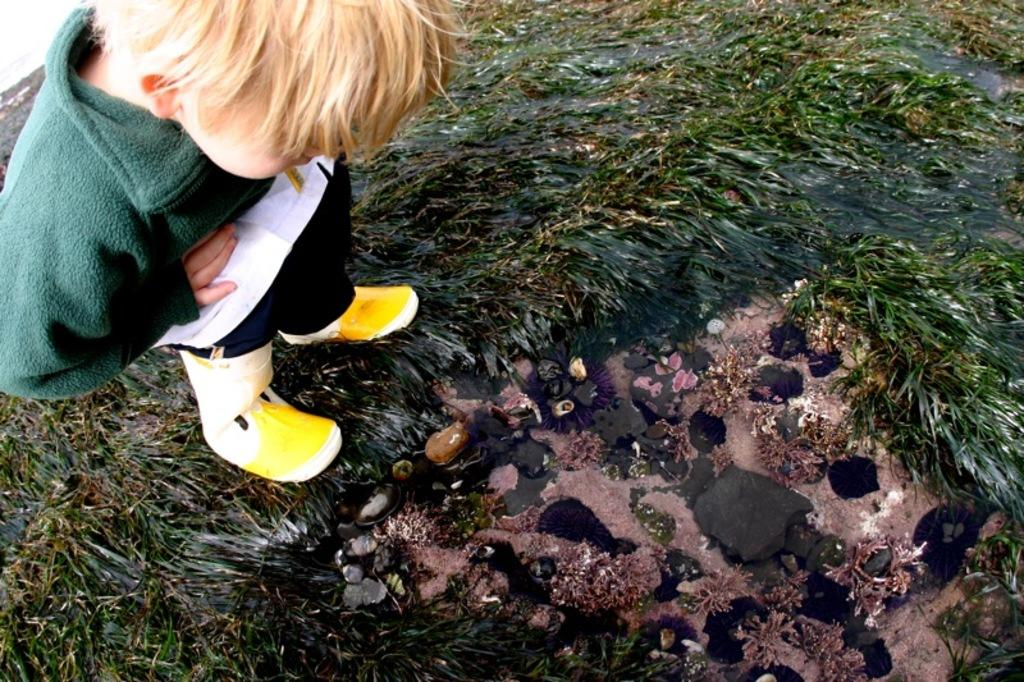What is the main subject of the image? The main subject of the image is a kid. Where is the kid located in the image? The kid is standing on the grass. What is the kid doing in the image? The kid is looking at something. What song is the kid singing in the image? There is no indication in the image that the kid is singing a song, so it cannot be determined from the picture. 